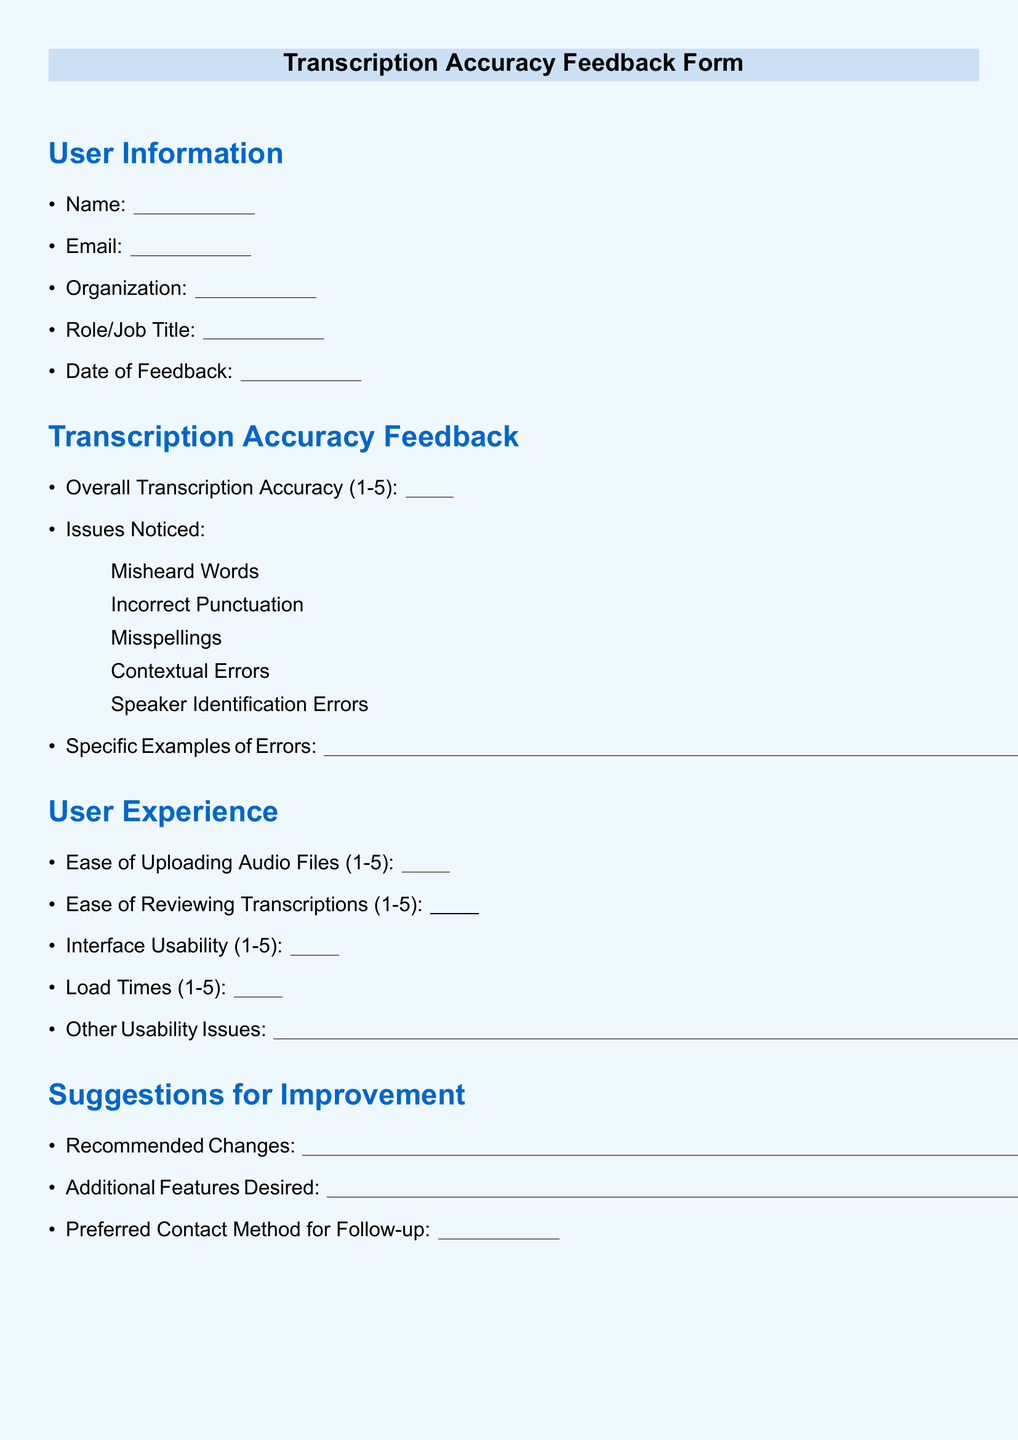What is the document title? The title of the document is presented prominently at the top of the page, indicating its purpose.
Answer: Transcription Accuracy Feedback Form Who is the intended recipient of the feedback? The sections of the document are designed for users providing feedback on transcription services, indicating they are the audience.
Answer: Users of the transcription service What rating scale is used for overall transcription accuracy? The document specifies a rating system from 1 to 5 for evaluating transcription accuracy.
Answer: 1-5 What section asks for specific examples of errors? The document contains a section that specifically requests users to provide examples of transcription errors.
Answer: Specific Examples of Errors What is the space provided for the user's name? The document includes a line for users to fill in their name, specifying the space allotted for this information.
Answer: 2.5 cm What is asked under the 'Ease of Uploading Audio Files' section? The document requests a rating from users regarding how easy it is to upload audio files, indicating usability insights.
Answer: Ease of Uploading Audio Files (1-5) What color is used for the headings? The document has specific color coding for different sections, which enhances visual organization.
Answer: RGB(0,102,204) What information is requested in the 'Suggestions for Improvement' section? This section seeks input from users on potential enhancements to the transcription service or features they wish to see added.
Answer: Recommended Changes What is the follow-up contact method asked for? The document indicates a section where users can specify their preferred way of being contacted for follow-up discussions regarding feedback.
Answer: Preferred Contact Method for Follow-up 